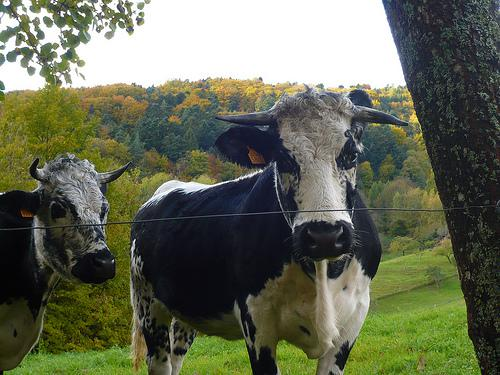Question: where are the cows?
Choices:
A. In the pen.
B. Inside the fenced area.
C. Behind the wire.
D. In the barn.
Answer with the letter. Answer: C Question: what animals are there?
Choices:
A. Horses.
B. Sheep.
C. Goats.
D. Cows.
Answer with the letter. Answer: D Question: what is behind the cows?
Choices:
A. Mountains.
B. Trees.
C. A barn.
D. A field.
Answer with the letter. Answer: B Question: how many cows are shown?
Choices:
A. Two.
B. One.
C. None.
D. Three.
Answer with the letter. Answer: A 